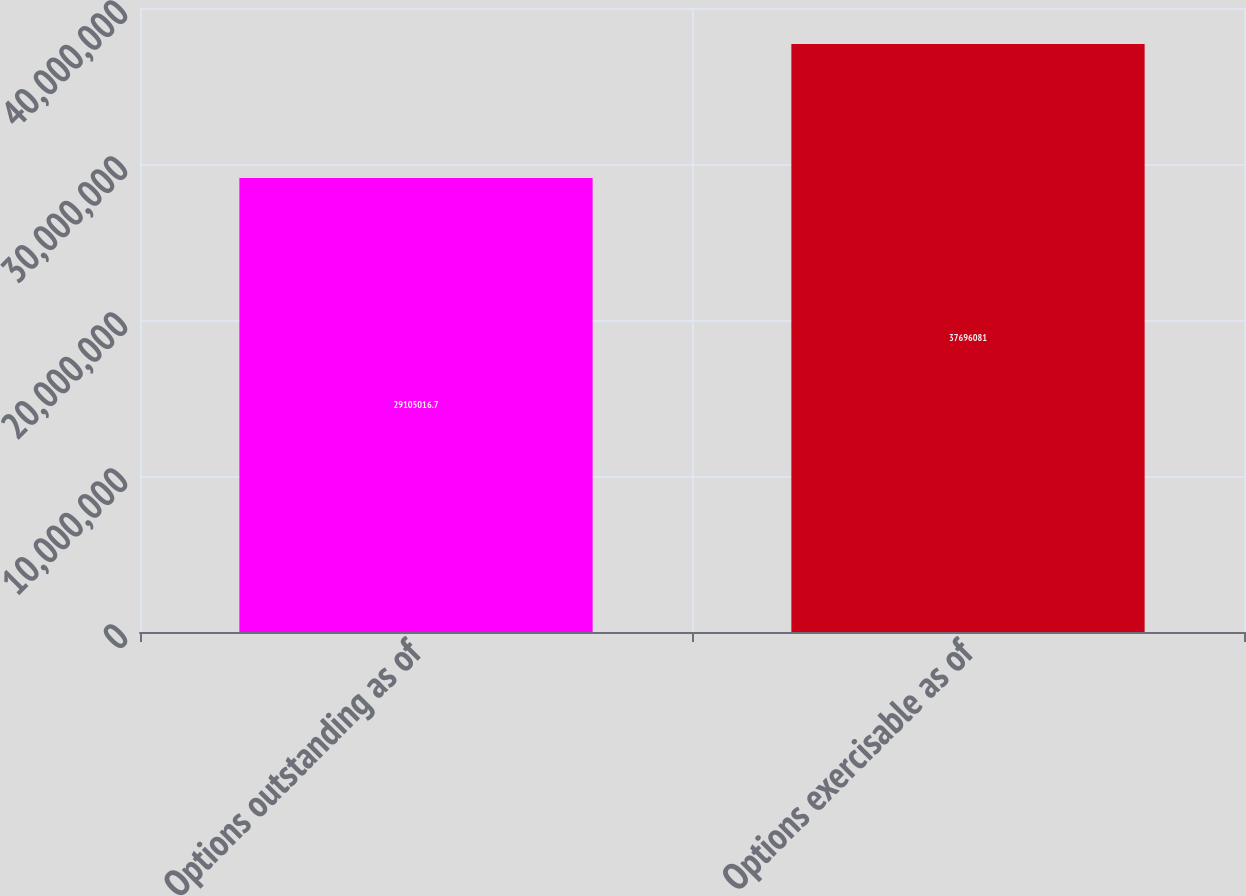Convert chart. <chart><loc_0><loc_0><loc_500><loc_500><bar_chart><fcel>Options outstanding as of<fcel>Options exercisable as of<nl><fcel>2.9105e+07<fcel>3.76961e+07<nl></chart> 